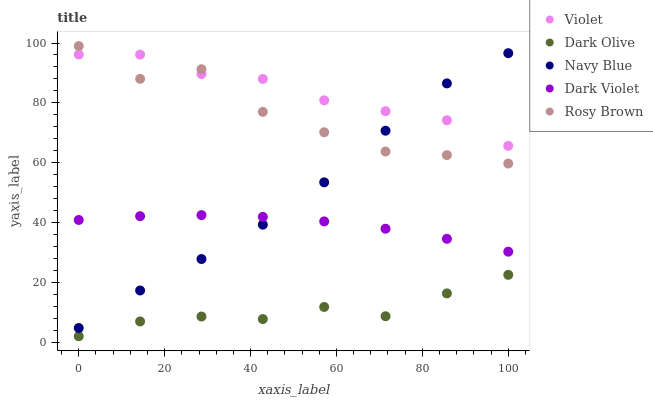Does Dark Olive have the minimum area under the curve?
Answer yes or no. Yes. Does Violet have the maximum area under the curve?
Answer yes or no. Yes. Does Rosy Brown have the minimum area under the curve?
Answer yes or no. No. Does Rosy Brown have the maximum area under the curve?
Answer yes or no. No. Is Dark Violet the smoothest?
Answer yes or no. Yes. Is Rosy Brown the roughest?
Answer yes or no. Yes. Is Dark Olive the smoothest?
Answer yes or no. No. Is Dark Olive the roughest?
Answer yes or no. No. Does Dark Olive have the lowest value?
Answer yes or no. Yes. Does Rosy Brown have the lowest value?
Answer yes or no. No. Does Rosy Brown have the highest value?
Answer yes or no. Yes. Does Dark Olive have the highest value?
Answer yes or no. No. Is Dark Olive less than Navy Blue?
Answer yes or no. Yes. Is Navy Blue greater than Dark Olive?
Answer yes or no. Yes. Does Rosy Brown intersect Violet?
Answer yes or no. Yes. Is Rosy Brown less than Violet?
Answer yes or no. No. Is Rosy Brown greater than Violet?
Answer yes or no. No. Does Dark Olive intersect Navy Blue?
Answer yes or no. No. 